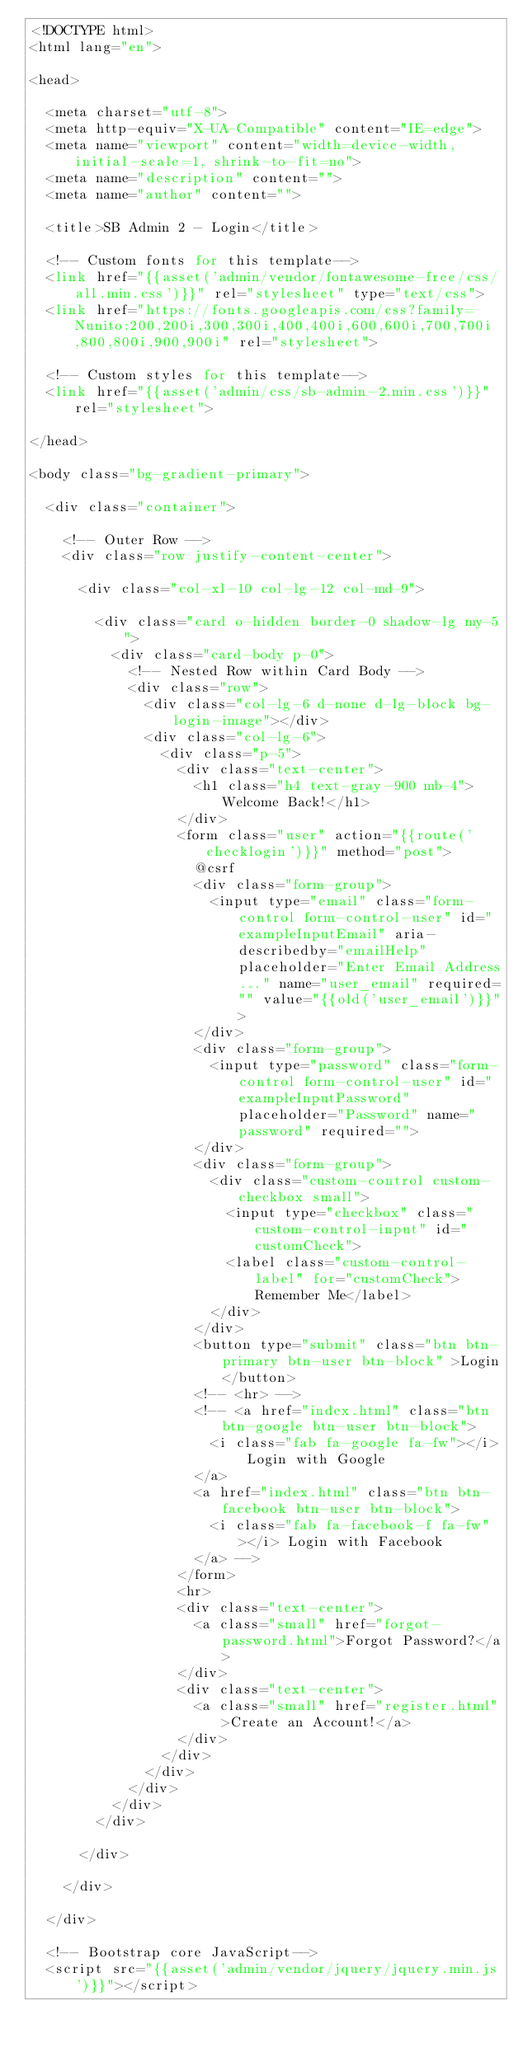Convert code to text. <code><loc_0><loc_0><loc_500><loc_500><_PHP_><!DOCTYPE html>
<html lang="en">

<head>

  <meta charset="utf-8">
  <meta http-equiv="X-UA-Compatible" content="IE=edge">
  <meta name="viewport" content="width=device-width, initial-scale=1, shrink-to-fit=no">
  <meta name="description" content="">
  <meta name="author" content="">

  <title>SB Admin 2 - Login</title>

  <!-- Custom fonts for this template-->
  <link href="{{asset('admin/vendor/fontawesome-free/css/all.min.css')}}" rel="stylesheet" type="text/css">
  <link href="https://fonts.googleapis.com/css?family=Nunito:200,200i,300,300i,400,400i,600,600i,700,700i,800,800i,900,900i" rel="stylesheet">

  <!-- Custom styles for this template-->
  <link href="{{asset('admin/css/sb-admin-2.min.css')}}" rel="stylesheet">

</head>

<body class="bg-gradient-primary">

  <div class="container">

    <!-- Outer Row -->
    <div class="row justify-content-center">

      <div class="col-xl-10 col-lg-12 col-md-9">

        <div class="card o-hidden border-0 shadow-lg my-5">
          <div class="card-body p-0">
            <!-- Nested Row within Card Body -->
            <div class="row">
              <div class="col-lg-6 d-none d-lg-block bg-login-image"></div>
              <div class="col-lg-6">
                <div class="p-5">
                  <div class="text-center">
                    <h1 class="h4 text-gray-900 mb-4">Welcome Back!</h1>
                  </div>
                  <form class="user" action="{{route('checklogin')}}" method="post">
                  	@csrf
                    <div class="form-group">
                      <input type="email" class="form-control form-control-user" id="exampleInputEmail" aria-describedby="emailHelp" placeholder="Enter Email Address..." name="user_email" required="" value="{{old('user_email')}}">
                    </div>
                    <div class="form-group">
                      <input type="password" class="form-control form-control-user" id="exampleInputPassword" placeholder="Password" name="password" required="">
                    </div>
                    <div class="form-group">
                      <div class="custom-control custom-checkbox small">
                        <input type="checkbox" class="custom-control-input" id="customCheck">
                        <label class="custom-control-label" for="customCheck">Remember Me</label>
                      </div>
                    </div>
                    <button type="submit" class="btn btn-primary btn-user btn-block" >Login</button>
                    <!-- <hr> -->
                    <!-- <a href="index.html" class="btn btn-google btn-user btn-block">
                      <i class="fab fa-google fa-fw"></i> Login with Google
                    </a>
                    <a href="index.html" class="btn btn-facebook btn-user btn-block">
                      <i class="fab fa-facebook-f fa-fw"></i> Login with Facebook
                    </a> -->
                  </form>
                  <hr>
                  <div class="text-center">
                    <a class="small" href="forgot-password.html">Forgot Password?</a>
                  </div>
                  <div class="text-center">
                    <a class="small" href="register.html">Create an Account!</a>
                  </div>
                </div>
              </div>
            </div>
          </div>
        </div>

      </div>

    </div>

  </div>

  <!-- Bootstrap core JavaScript-->
  <script src="{{asset('admin/vendor/jquery/jquery.min.js')}}"></script></code> 